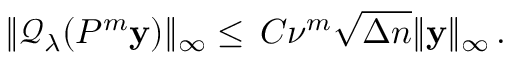Convert formula to latex. <formula><loc_0><loc_0><loc_500><loc_500>\begin{array} { r } { \| \mathcal { Q } _ { \lambda } ( P ^ { m } y ) \| _ { \infty } \leq \, C \nu ^ { m } \sqrt { \Delta n } \| y \| _ { \infty } \, . } \end{array}</formula> 